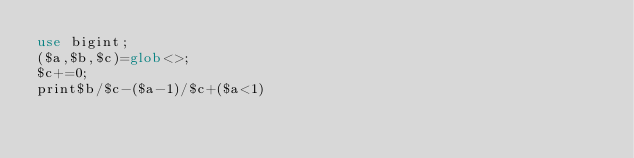<code> <loc_0><loc_0><loc_500><loc_500><_Perl_>use bigint;
($a,$b,$c)=glob<>;
$c+=0;
print$b/$c-($a-1)/$c+($a<1)</code> 